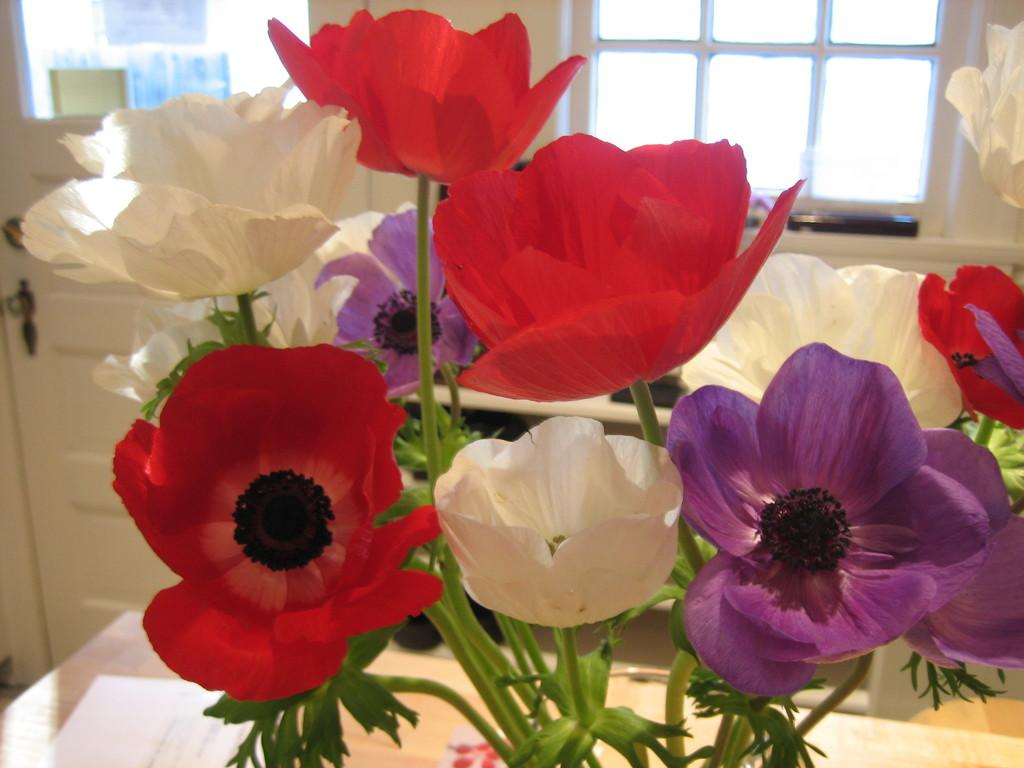What type of vegetation is present in the front of the image? There are flowers in the front of the image. What architectural features can be seen in the background of the image? There is a window and a door in the background of the image. What color are the door and window in the image? The door and window are white in color. Can you tell me how many guitars are being traded in the image? There are no guitars or references to trading in the image; it features flowers, a window, and a door. What part of the brain is visible in the image? There is no brain present in the image. 